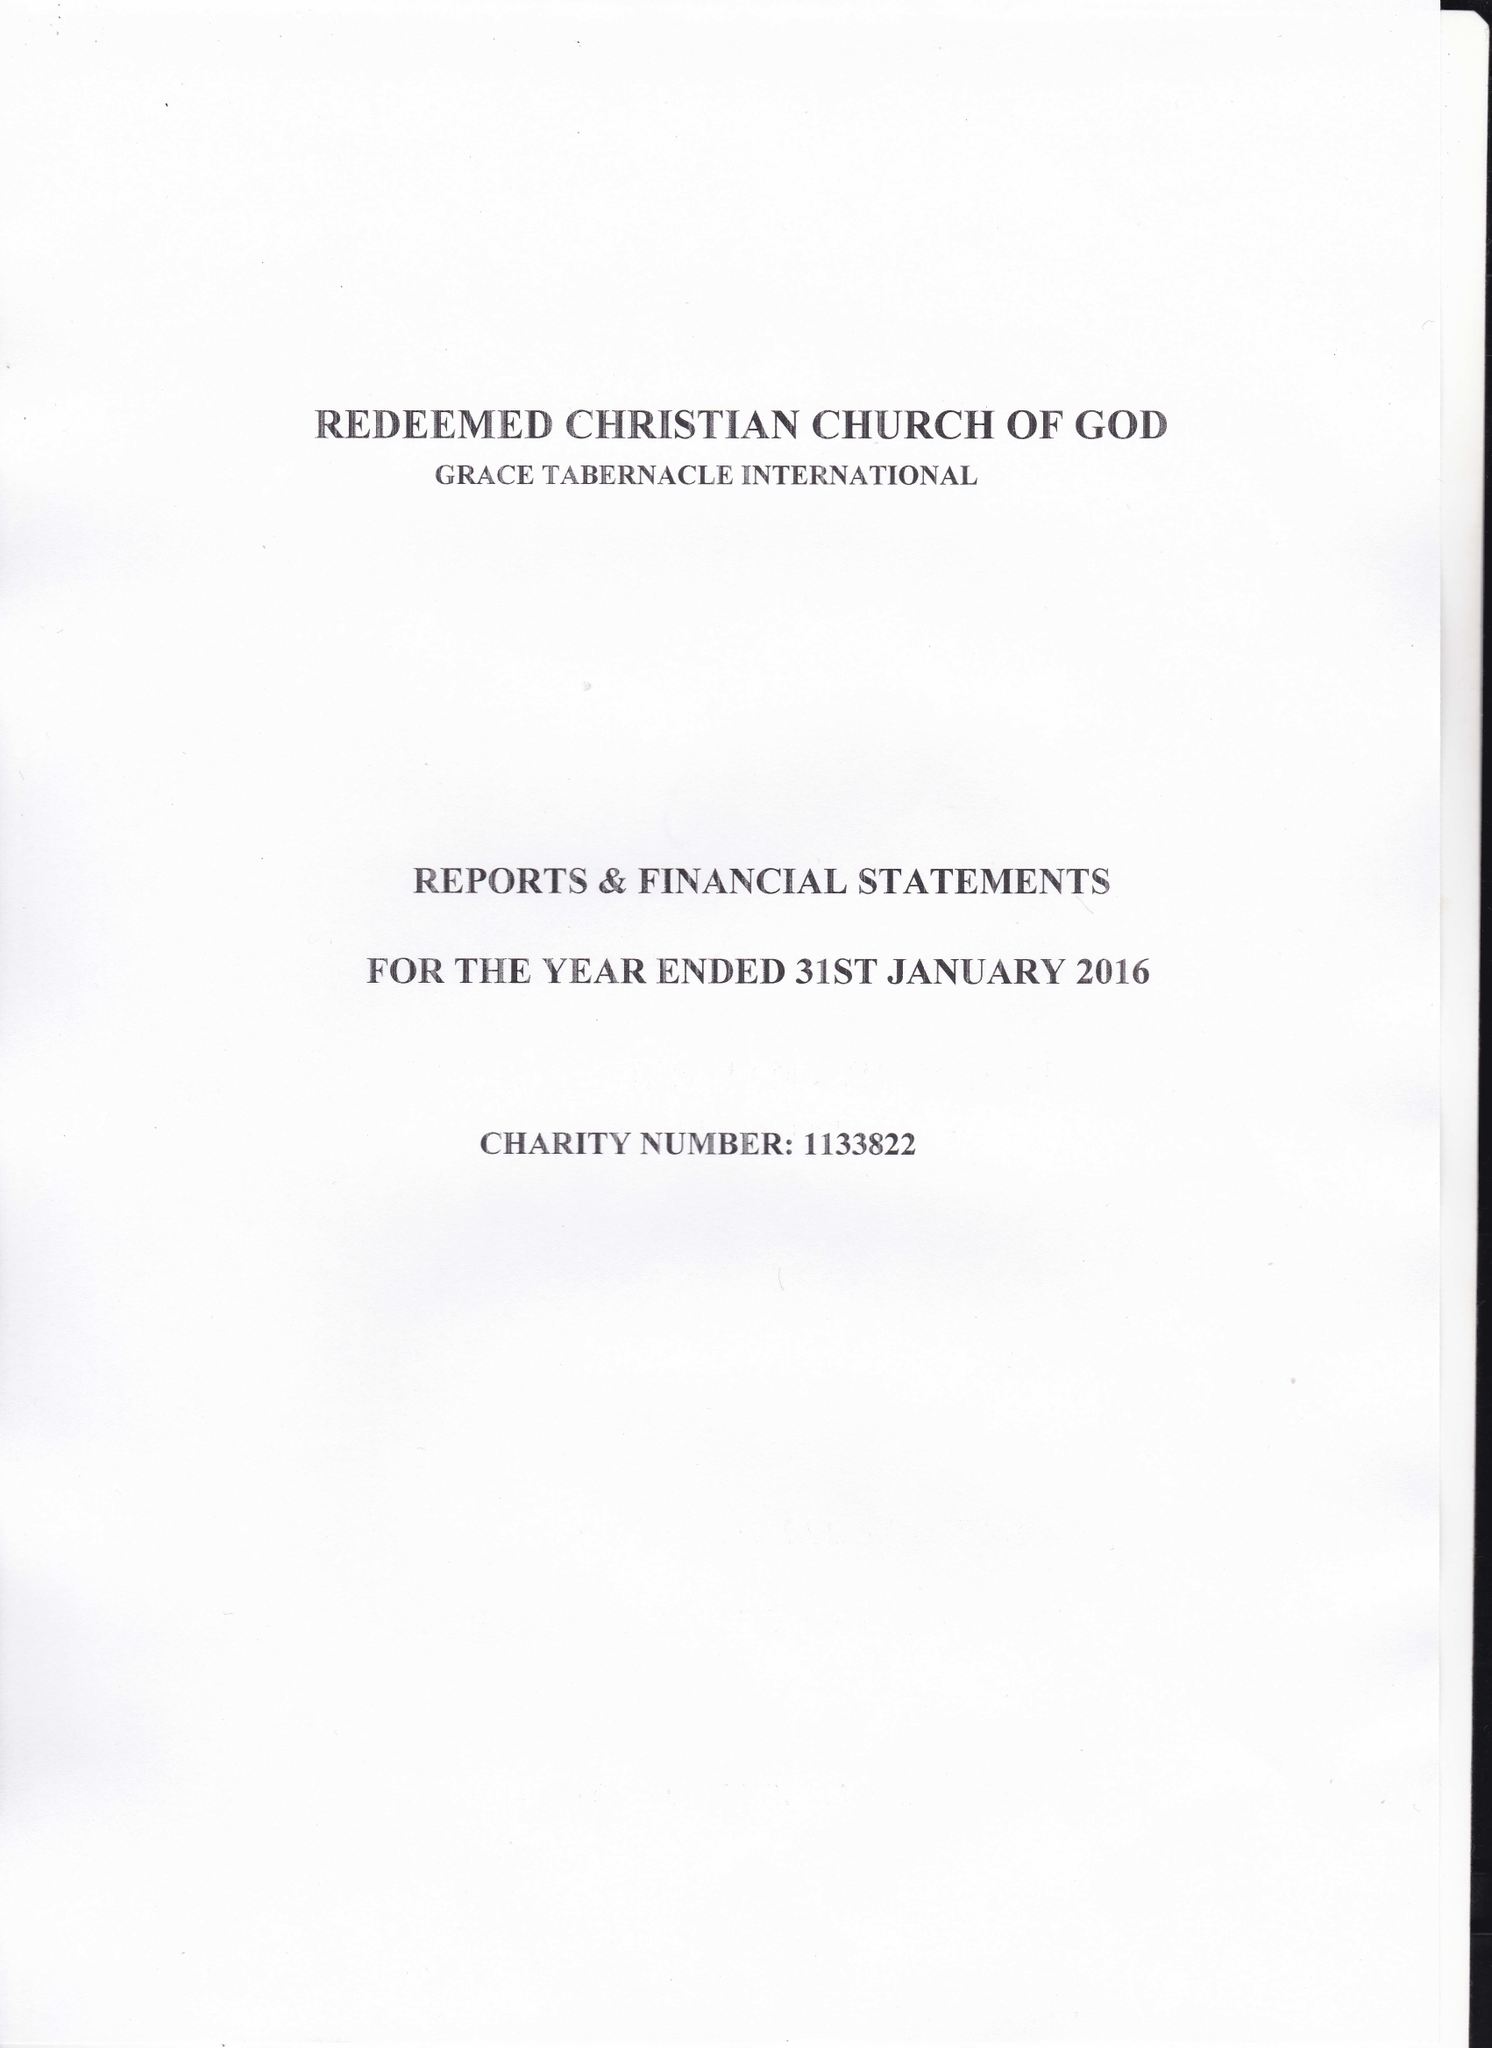What is the value for the income_annually_in_british_pounds?
Answer the question using a single word or phrase. 33842.00 